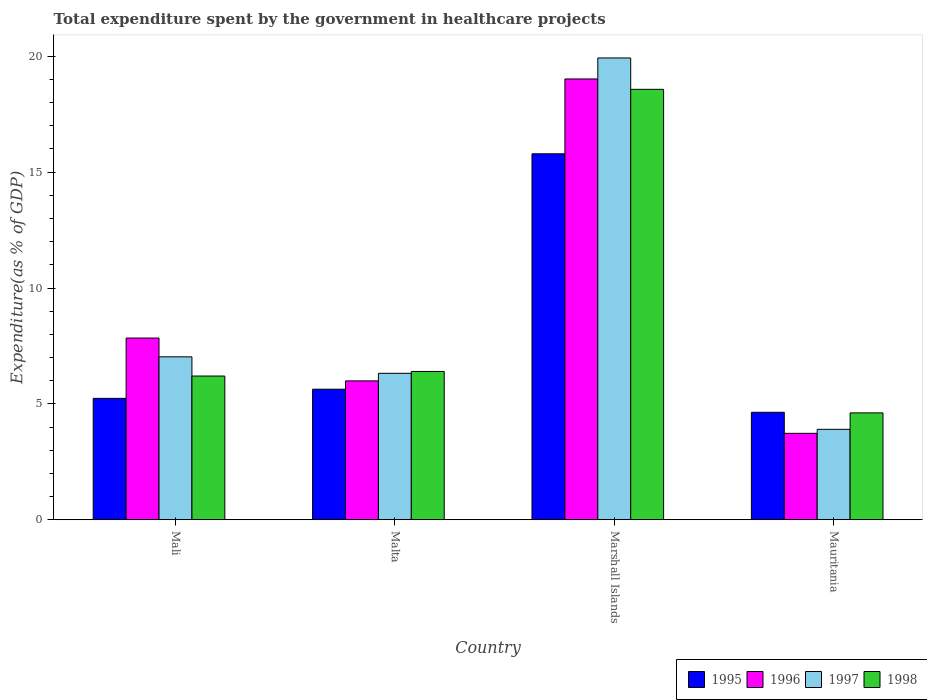Are the number of bars per tick equal to the number of legend labels?
Keep it short and to the point. Yes. Are the number of bars on each tick of the X-axis equal?
Provide a succinct answer. Yes. How many bars are there on the 3rd tick from the left?
Give a very brief answer. 4. How many bars are there on the 3rd tick from the right?
Give a very brief answer. 4. What is the label of the 4th group of bars from the left?
Your answer should be very brief. Mauritania. In how many cases, is the number of bars for a given country not equal to the number of legend labels?
Offer a terse response. 0. What is the total expenditure spent by the government in healthcare projects in 1995 in Malta?
Give a very brief answer. 5.63. Across all countries, what is the maximum total expenditure spent by the government in healthcare projects in 1997?
Your answer should be compact. 19.93. Across all countries, what is the minimum total expenditure spent by the government in healthcare projects in 1996?
Provide a succinct answer. 3.73. In which country was the total expenditure spent by the government in healthcare projects in 1997 maximum?
Your answer should be very brief. Marshall Islands. In which country was the total expenditure spent by the government in healthcare projects in 1997 minimum?
Provide a succinct answer. Mauritania. What is the total total expenditure spent by the government in healthcare projects in 1998 in the graph?
Make the answer very short. 35.78. What is the difference between the total expenditure spent by the government in healthcare projects in 1998 in Malta and that in Marshall Islands?
Give a very brief answer. -12.17. What is the difference between the total expenditure spent by the government in healthcare projects in 1997 in Mali and the total expenditure spent by the government in healthcare projects in 1996 in Mauritania?
Give a very brief answer. 3.3. What is the average total expenditure spent by the government in healthcare projects in 1997 per country?
Provide a short and direct response. 9.29. What is the difference between the total expenditure spent by the government in healthcare projects of/in 1995 and total expenditure spent by the government in healthcare projects of/in 1996 in Mali?
Your answer should be compact. -2.6. What is the ratio of the total expenditure spent by the government in healthcare projects in 1998 in Mali to that in Marshall Islands?
Keep it short and to the point. 0.33. Is the total expenditure spent by the government in healthcare projects in 1998 in Malta less than that in Mauritania?
Your answer should be very brief. No. Is the difference between the total expenditure spent by the government in healthcare projects in 1995 in Marshall Islands and Mauritania greater than the difference between the total expenditure spent by the government in healthcare projects in 1996 in Marshall Islands and Mauritania?
Ensure brevity in your answer.  No. What is the difference between the highest and the second highest total expenditure spent by the government in healthcare projects in 1995?
Ensure brevity in your answer.  -0.4. What is the difference between the highest and the lowest total expenditure spent by the government in healthcare projects in 1996?
Keep it short and to the point. 15.29. Is the sum of the total expenditure spent by the government in healthcare projects in 1996 in Malta and Mauritania greater than the maximum total expenditure spent by the government in healthcare projects in 1998 across all countries?
Ensure brevity in your answer.  No. Is it the case that in every country, the sum of the total expenditure spent by the government in healthcare projects in 1996 and total expenditure spent by the government in healthcare projects in 1998 is greater than the sum of total expenditure spent by the government in healthcare projects in 1997 and total expenditure spent by the government in healthcare projects in 1995?
Offer a very short reply. No. What does the 2nd bar from the right in Marshall Islands represents?
Provide a short and direct response. 1997. Is it the case that in every country, the sum of the total expenditure spent by the government in healthcare projects in 1995 and total expenditure spent by the government in healthcare projects in 1998 is greater than the total expenditure spent by the government in healthcare projects in 1997?
Your response must be concise. Yes. How many bars are there?
Ensure brevity in your answer.  16. Are all the bars in the graph horizontal?
Your response must be concise. No. How many countries are there in the graph?
Give a very brief answer. 4. Are the values on the major ticks of Y-axis written in scientific E-notation?
Offer a terse response. No. Does the graph contain any zero values?
Offer a very short reply. No. How many legend labels are there?
Give a very brief answer. 4. What is the title of the graph?
Your response must be concise. Total expenditure spent by the government in healthcare projects. What is the label or title of the Y-axis?
Provide a short and direct response. Expenditure(as % of GDP). What is the Expenditure(as % of GDP) of 1995 in Mali?
Give a very brief answer. 5.24. What is the Expenditure(as % of GDP) of 1996 in Mali?
Keep it short and to the point. 7.84. What is the Expenditure(as % of GDP) of 1997 in Mali?
Your answer should be very brief. 7.03. What is the Expenditure(as % of GDP) in 1998 in Mali?
Provide a succinct answer. 6.2. What is the Expenditure(as % of GDP) in 1995 in Malta?
Offer a terse response. 5.63. What is the Expenditure(as % of GDP) of 1996 in Malta?
Provide a short and direct response. 5.99. What is the Expenditure(as % of GDP) of 1997 in Malta?
Give a very brief answer. 6.32. What is the Expenditure(as % of GDP) of 1998 in Malta?
Make the answer very short. 6.4. What is the Expenditure(as % of GDP) of 1995 in Marshall Islands?
Your answer should be compact. 15.79. What is the Expenditure(as % of GDP) of 1996 in Marshall Islands?
Make the answer very short. 19.02. What is the Expenditure(as % of GDP) of 1997 in Marshall Islands?
Make the answer very short. 19.93. What is the Expenditure(as % of GDP) in 1998 in Marshall Islands?
Keep it short and to the point. 18.57. What is the Expenditure(as % of GDP) in 1995 in Mauritania?
Offer a very short reply. 4.64. What is the Expenditure(as % of GDP) in 1996 in Mauritania?
Provide a short and direct response. 3.73. What is the Expenditure(as % of GDP) of 1997 in Mauritania?
Give a very brief answer. 3.9. What is the Expenditure(as % of GDP) of 1998 in Mauritania?
Offer a terse response. 4.61. Across all countries, what is the maximum Expenditure(as % of GDP) in 1995?
Offer a very short reply. 15.79. Across all countries, what is the maximum Expenditure(as % of GDP) in 1996?
Your response must be concise. 19.02. Across all countries, what is the maximum Expenditure(as % of GDP) in 1997?
Offer a very short reply. 19.93. Across all countries, what is the maximum Expenditure(as % of GDP) of 1998?
Give a very brief answer. 18.57. Across all countries, what is the minimum Expenditure(as % of GDP) in 1995?
Offer a terse response. 4.64. Across all countries, what is the minimum Expenditure(as % of GDP) in 1996?
Make the answer very short. 3.73. Across all countries, what is the minimum Expenditure(as % of GDP) of 1997?
Provide a short and direct response. 3.9. Across all countries, what is the minimum Expenditure(as % of GDP) in 1998?
Ensure brevity in your answer.  4.61. What is the total Expenditure(as % of GDP) of 1995 in the graph?
Your answer should be very brief. 31.3. What is the total Expenditure(as % of GDP) in 1996 in the graph?
Ensure brevity in your answer.  36.58. What is the total Expenditure(as % of GDP) in 1997 in the graph?
Ensure brevity in your answer.  37.18. What is the total Expenditure(as % of GDP) in 1998 in the graph?
Your answer should be very brief. 35.78. What is the difference between the Expenditure(as % of GDP) of 1995 in Mali and that in Malta?
Offer a very short reply. -0.4. What is the difference between the Expenditure(as % of GDP) of 1996 in Mali and that in Malta?
Ensure brevity in your answer.  1.85. What is the difference between the Expenditure(as % of GDP) of 1997 in Mali and that in Malta?
Ensure brevity in your answer.  0.71. What is the difference between the Expenditure(as % of GDP) in 1998 in Mali and that in Malta?
Provide a short and direct response. -0.2. What is the difference between the Expenditure(as % of GDP) of 1995 in Mali and that in Marshall Islands?
Provide a succinct answer. -10.55. What is the difference between the Expenditure(as % of GDP) of 1996 in Mali and that in Marshall Islands?
Give a very brief answer. -11.18. What is the difference between the Expenditure(as % of GDP) in 1997 in Mali and that in Marshall Islands?
Your response must be concise. -12.9. What is the difference between the Expenditure(as % of GDP) of 1998 in Mali and that in Marshall Islands?
Ensure brevity in your answer.  -12.37. What is the difference between the Expenditure(as % of GDP) of 1995 in Mali and that in Mauritania?
Make the answer very short. 0.6. What is the difference between the Expenditure(as % of GDP) in 1996 in Mali and that in Mauritania?
Your answer should be very brief. 4.11. What is the difference between the Expenditure(as % of GDP) in 1997 in Mali and that in Mauritania?
Offer a terse response. 3.13. What is the difference between the Expenditure(as % of GDP) of 1998 in Mali and that in Mauritania?
Your answer should be very brief. 1.59. What is the difference between the Expenditure(as % of GDP) in 1995 in Malta and that in Marshall Islands?
Keep it short and to the point. -10.16. What is the difference between the Expenditure(as % of GDP) of 1996 in Malta and that in Marshall Islands?
Keep it short and to the point. -13.03. What is the difference between the Expenditure(as % of GDP) of 1997 in Malta and that in Marshall Islands?
Your answer should be compact. -13.61. What is the difference between the Expenditure(as % of GDP) in 1998 in Malta and that in Marshall Islands?
Provide a short and direct response. -12.17. What is the difference between the Expenditure(as % of GDP) in 1995 in Malta and that in Mauritania?
Your answer should be very brief. 1. What is the difference between the Expenditure(as % of GDP) of 1996 in Malta and that in Mauritania?
Keep it short and to the point. 2.26. What is the difference between the Expenditure(as % of GDP) of 1997 in Malta and that in Mauritania?
Give a very brief answer. 2.42. What is the difference between the Expenditure(as % of GDP) in 1998 in Malta and that in Mauritania?
Your response must be concise. 1.79. What is the difference between the Expenditure(as % of GDP) of 1995 in Marshall Islands and that in Mauritania?
Provide a short and direct response. 11.15. What is the difference between the Expenditure(as % of GDP) of 1996 in Marshall Islands and that in Mauritania?
Provide a short and direct response. 15.29. What is the difference between the Expenditure(as % of GDP) in 1997 in Marshall Islands and that in Mauritania?
Your answer should be very brief. 16.02. What is the difference between the Expenditure(as % of GDP) in 1998 in Marshall Islands and that in Mauritania?
Provide a short and direct response. 13.96. What is the difference between the Expenditure(as % of GDP) of 1995 in Mali and the Expenditure(as % of GDP) of 1996 in Malta?
Provide a succinct answer. -0.75. What is the difference between the Expenditure(as % of GDP) of 1995 in Mali and the Expenditure(as % of GDP) of 1997 in Malta?
Give a very brief answer. -1.08. What is the difference between the Expenditure(as % of GDP) of 1995 in Mali and the Expenditure(as % of GDP) of 1998 in Malta?
Your answer should be compact. -1.16. What is the difference between the Expenditure(as % of GDP) in 1996 in Mali and the Expenditure(as % of GDP) in 1997 in Malta?
Ensure brevity in your answer.  1.52. What is the difference between the Expenditure(as % of GDP) in 1996 in Mali and the Expenditure(as % of GDP) in 1998 in Malta?
Offer a very short reply. 1.44. What is the difference between the Expenditure(as % of GDP) of 1997 in Mali and the Expenditure(as % of GDP) of 1998 in Malta?
Your response must be concise. 0.63. What is the difference between the Expenditure(as % of GDP) of 1995 in Mali and the Expenditure(as % of GDP) of 1996 in Marshall Islands?
Keep it short and to the point. -13.78. What is the difference between the Expenditure(as % of GDP) in 1995 in Mali and the Expenditure(as % of GDP) in 1997 in Marshall Islands?
Give a very brief answer. -14.69. What is the difference between the Expenditure(as % of GDP) of 1995 in Mali and the Expenditure(as % of GDP) of 1998 in Marshall Islands?
Keep it short and to the point. -13.33. What is the difference between the Expenditure(as % of GDP) in 1996 in Mali and the Expenditure(as % of GDP) in 1997 in Marshall Islands?
Make the answer very short. -12.08. What is the difference between the Expenditure(as % of GDP) in 1996 in Mali and the Expenditure(as % of GDP) in 1998 in Marshall Islands?
Provide a short and direct response. -10.73. What is the difference between the Expenditure(as % of GDP) in 1997 in Mali and the Expenditure(as % of GDP) in 1998 in Marshall Islands?
Provide a short and direct response. -11.54. What is the difference between the Expenditure(as % of GDP) of 1995 in Mali and the Expenditure(as % of GDP) of 1996 in Mauritania?
Your answer should be compact. 1.51. What is the difference between the Expenditure(as % of GDP) of 1995 in Mali and the Expenditure(as % of GDP) of 1997 in Mauritania?
Your answer should be compact. 1.34. What is the difference between the Expenditure(as % of GDP) in 1995 in Mali and the Expenditure(as % of GDP) in 1998 in Mauritania?
Your answer should be very brief. 0.63. What is the difference between the Expenditure(as % of GDP) in 1996 in Mali and the Expenditure(as % of GDP) in 1997 in Mauritania?
Provide a short and direct response. 3.94. What is the difference between the Expenditure(as % of GDP) of 1996 in Mali and the Expenditure(as % of GDP) of 1998 in Mauritania?
Give a very brief answer. 3.23. What is the difference between the Expenditure(as % of GDP) in 1997 in Mali and the Expenditure(as % of GDP) in 1998 in Mauritania?
Provide a short and direct response. 2.42. What is the difference between the Expenditure(as % of GDP) in 1995 in Malta and the Expenditure(as % of GDP) in 1996 in Marshall Islands?
Offer a terse response. -13.39. What is the difference between the Expenditure(as % of GDP) of 1995 in Malta and the Expenditure(as % of GDP) of 1997 in Marshall Islands?
Offer a very short reply. -14.29. What is the difference between the Expenditure(as % of GDP) in 1995 in Malta and the Expenditure(as % of GDP) in 1998 in Marshall Islands?
Ensure brevity in your answer.  -12.94. What is the difference between the Expenditure(as % of GDP) of 1996 in Malta and the Expenditure(as % of GDP) of 1997 in Marshall Islands?
Provide a short and direct response. -13.93. What is the difference between the Expenditure(as % of GDP) in 1996 in Malta and the Expenditure(as % of GDP) in 1998 in Marshall Islands?
Provide a short and direct response. -12.58. What is the difference between the Expenditure(as % of GDP) in 1997 in Malta and the Expenditure(as % of GDP) in 1998 in Marshall Islands?
Your answer should be very brief. -12.25. What is the difference between the Expenditure(as % of GDP) in 1995 in Malta and the Expenditure(as % of GDP) in 1996 in Mauritania?
Give a very brief answer. 1.9. What is the difference between the Expenditure(as % of GDP) in 1995 in Malta and the Expenditure(as % of GDP) in 1997 in Mauritania?
Your response must be concise. 1.73. What is the difference between the Expenditure(as % of GDP) of 1995 in Malta and the Expenditure(as % of GDP) of 1998 in Mauritania?
Ensure brevity in your answer.  1.02. What is the difference between the Expenditure(as % of GDP) in 1996 in Malta and the Expenditure(as % of GDP) in 1997 in Mauritania?
Give a very brief answer. 2.09. What is the difference between the Expenditure(as % of GDP) in 1996 in Malta and the Expenditure(as % of GDP) in 1998 in Mauritania?
Keep it short and to the point. 1.38. What is the difference between the Expenditure(as % of GDP) of 1997 in Malta and the Expenditure(as % of GDP) of 1998 in Mauritania?
Offer a terse response. 1.71. What is the difference between the Expenditure(as % of GDP) in 1995 in Marshall Islands and the Expenditure(as % of GDP) in 1996 in Mauritania?
Provide a short and direct response. 12.06. What is the difference between the Expenditure(as % of GDP) in 1995 in Marshall Islands and the Expenditure(as % of GDP) in 1997 in Mauritania?
Offer a very short reply. 11.89. What is the difference between the Expenditure(as % of GDP) of 1995 in Marshall Islands and the Expenditure(as % of GDP) of 1998 in Mauritania?
Provide a short and direct response. 11.18. What is the difference between the Expenditure(as % of GDP) of 1996 in Marshall Islands and the Expenditure(as % of GDP) of 1997 in Mauritania?
Make the answer very short. 15.12. What is the difference between the Expenditure(as % of GDP) in 1996 in Marshall Islands and the Expenditure(as % of GDP) in 1998 in Mauritania?
Keep it short and to the point. 14.41. What is the difference between the Expenditure(as % of GDP) of 1997 in Marshall Islands and the Expenditure(as % of GDP) of 1998 in Mauritania?
Make the answer very short. 15.31. What is the average Expenditure(as % of GDP) of 1995 per country?
Your answer should be very brief. 7.82. What is the average Expenditure(as % of GDP) of 1996 per country?
Keep it short and to the point. 9.15. What is the average Expenditure(as % of GDP) of 1997 per country?
Offer a terse response. 9.29. What is the average Expenditure(as % of GDP) of 1998 per country?
Make the answer very short. 8.95. What is the difference between the Expenditure(as % of GDP) of 1995 and Expenditure(as % of GDP) of 1996 in Mali?
Your answer should be compact. -2.6. What is the difference between the Expenditure(as % of GDP) in 1995 and Expenditure(as % of GDP) in 1997 in Mali?
Your answer should be compact. -1.79. What is the difference between the Expenditure(as % of GDP) in 1995 and Expenditure(as % of GDP) in 1998 in Mali?
Your answer should be compact. -0.96. What is the difference between the Expenditure(as % of GDP) in 1996 and Expenditure(as % of GDP) in 1997 in Mali?
Give a very brief answer. 0.81. What is the difference between the Expenditure(as % of GDP) of 1996 and Expenditure(as % of GDP) of 1998 in Mali?
Offer a terse response. 1.64. What is the difference between the Expenditure(as % of GDP) of 1997 and Expenditure(as % of GDP) of 1998 in Mali?
Your response must be concise. 0.83. What is the difference between the Expenditure(as % of GDP) in 1995 and Expenditure(as % of GDP) in 1996 in Malta?
Your response must be concise. -0.36. What is the difference between the Expenditure(as % of GDP) in 1995 and Expenditure(as % of GDP) in 1997 in Malta?
Provide a succinct answer. -0.69. What is the difference between the Expenditure(as % of GDP) in 1995 and Expenditure(as % of GDP) in 1998 in Malta?
Keep it short and to the point. -0.77. What is the difference between the Expenditure(as % of GDP) in 1996 and Expenditure(as % of GDP) in 1997 in Malta?
Your response must be concise. -0.33. What is the difference between the Expenditure(as % of GDP) in 1996 and Expenditure(as % of GDP) in 1998 in Malta?
Offer a terse response. -0.41. What is the difference between the Expenditure(as % of GDP) in 1997 and Expenditure(as % of GDP) in 1998 in Malta?
Ensure brevity in your answer.  -0.08. What is the difference between the Expenditure(as % of GDP) of 1995 and Expenditure(as % of GDP) of 1996 in Marshall Islands?
Offer a very short reply. -3.23. What is the difference between the Expenditure(as % of GDP) in 1995 and Expenditure(as % of GDP) in 1997 in Marshall Islands?
Make the answer very short. -4.14. What is the difference between the Expenditure(as % of GDP) in 1995 and Expenditure(as % of GDP) in 1998 in Marshall Islands?
Your response must be concise. -2.78. What is the difference between the Expenditure(as % of GDP) in 1996 and Expenditure(as % of GDP) in 1997 in Marshall Islands?
Offer a very short reply. -0.91. What is the difference between the Expenditure(as % of GDP) of 1996 and Expenditure(as % of GDP) of 1998 in Marshall Islands?
Offer a terse response. 0.45. What is the difference between the Expenditure(as % of GDP) in 1997 and Expenditure(as % of GDP) in 1998 in Marshall Islands?
Offer a very short reply. 1.35. What is the difference between the Expenditure(as % of GDP) of 1995 and Expenditure(as % of GDP) of 1996 in Mauritania?
Give a very brief answer. 0.91. What is the difference between the Expenditure(as % of GDP) of 1995 and Expenditure(as % of GDP) of 1997 in Mauritania?
Offer a very short reply. 0.73. What is the difference between the Expenditure(as % of GDP) of 1995 and Expenditure(as % of GDP) of 1998 in Mauritania?
Give a very brief answer. 0.03. What is the difference between the Expenditure(as % of GDP) of 1996 and Expenditure(as % of GDP) of 1997 in Mauritania?
Your answer should be compact. -0.17. What is the difference between the Expenditure(as % of GDP) in 1996 and Expenditure(as % of GDP) in 1998 in Mauritania?
Ensure brevity in your answer.  -0.88. What is the difference between the Expenditure(as % of GDP) of 1997 and Expenditure(as % of GDP) of 1998 in Mauritania?
Make the answer very short. -0.71. What is the ratio of the Expenditure(as % of GDP) of 1995 in Mali to that in Malta?
Your answer should be compact. 0.93. What is the ratio of the Expenditure(as % of GDP) of 1996 in Mali to that in Malta?
Provide a succinct answer. 1.31. What is the ratio of the Expenditure(as % of GDP) in 1997 in Mali to that in Malta?
Your answer should be very brief. 1.11. What is the ratio of the Expenditure(as % of GDP) in 1998 in Mali to that in Malta?
Ensure brevity in your answer.  0.97. What is the ratio of the Expenditure(as % of GDP) in 1995 in Mali to that in Marshall Islands?
Offer a very short reply. 0.33. What is the ratio of the Expenditure(as % of GDP) of 1996 in Mali to that in Marshall Islands?
Offer a terse response. 0.41. What is the ratio of the Expenditure(as % of GDP) of 1997 in Mali to that in Marshall Islands?
Ensure brevity in your answer.  0.35. What is the ratio of the Expenditure(as % of GDP) of 1998 in Mali to that in Marshall Islands?
Your answer should be compact. 0.33. What is the ratio of the Expenditure(as % of GDP) of 1995 in Mali to that in Mauritania?
Your answer should be very brief. 1.13. What is the ratio of the Expenditure(as % of GDP) of 1996 in Mali to that in Mauritania?
Your answer should be compact. 2.1. What is the ratio of the Expenditure(as % of GDP) of 1997 in Mali to that in Mauritania?
Your answer should be compact. 1.8. What is the ratio of the Expenditure(as % of GDP) of 1998 in Mali to that in Mauritania?
Ensure brevity in your answer.  1.34. What is the ratio of the Expenditure(as % of GDP) in 1995 in Malta to that in Marshall Islands?
Your answer should be compact. 0.36. What is the ratio of the Expenditure(as % of GDP) in 1996 in Malta to that in Marshall Islands?
Keep it short and to the point. 0.32. What is the ratio of the Expenditure(as % of GDP) in 1997 in Malta to that in Marshall Islands?
Make the answer very short. 0.32. What is the ratio of the Expenditure(as % of GDP) in 1998 in Malta to that in Marshall Islands?
Offer a terse response. 0.34. What is the ratio of the Expenditure(as % of GDP) in 1995 in Malta to that in Mauritania?
Your answer should be compact. 1.21. What is the ratio of the Expenditure(as % of GDP) in 1996 in Malta to that in Mauritania?
Ensure brevity in your answer.  1.61. What is the ratio of the Expenditure(as % of GDP) of 1997 in Malta to that in Mauritania?
Give a very brief answer. 1.62. What is the ratio of the Expenditure(as % of GDP) in 1998 in Malta to that in Mauritania?
Your answer should be compact. 1.39. What is the ratio of the Expenditure(as % of GDP) in 1995 in Marshall Islands to that in Mauritania?
Offer a very short reply. 3.41. What is the ratio of the Expenditure(as % of GDP) in 1996 in Marshall Islands to that in Mauritania?
Ensure brevity in your answer.  5.1. What is the ratio of the Expenditure(as % of GDP) in 1997 in Marshall Islands to that in Mauritania?
Your answer should be very brief. 5.11. What is the ratio of the Expenditure(as % of GDP) of 1998 in Marshall Islands to that in Mauritania?
Give a very brief answer. 4.03. What is the difference between the highest and the second highest Expenditure(as % of GDP) in 1995?
Make the answer very short. 10.16. What is the difference between the highest and the second highest Expenditure(as % of GDP) in 1996?
Offer a very short reply. 11.18. What is the difference between the highest and the second highest Expenditure(as % of GDP) of 1997?
Provide a short and direct response. 12.9. What is the difference between the highest and the second highest Expenditure(as % of GDP) in 1998?
Provide a succinct answer. 12.17. What is the difference between the highest and the lowest Expenditure(as % of GDP) of 1995?
Provide a short and direct response. 11.15. What is the difference between the highest and the lowest Expenditure(as % of GDP) in 1996?
Your answer should be very brief. 15.29. What is the difference between the highest and the lowest Expenditure(as % of GDP) of 1997?
Your answer should be very brief. 16.02. What is the difference between the highest and the lowest Expenditure(as % of GDP) in 1998?
Keep it short and to the point. 13.96. 